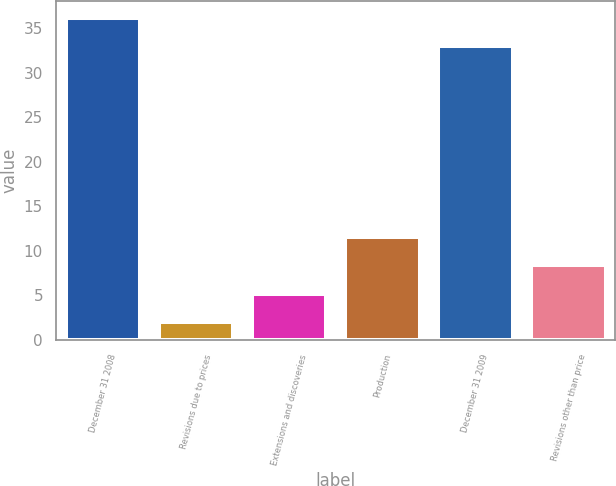Convert chart to OTSL. <chart><loc_0><loc_0><loc_500><loc_500><bar_chart><fcel>December 31 2008<fcel>Revisions due to prices<fcel>Extensions and discoveries<fcel>Production<fcel>December 31 2009<fcel>Revisions other than price<nl><fcel>36.2<fcel>2<fcel>5.2<fcel>11.6<fcel>33<fcel>8.4<nl></chart> 